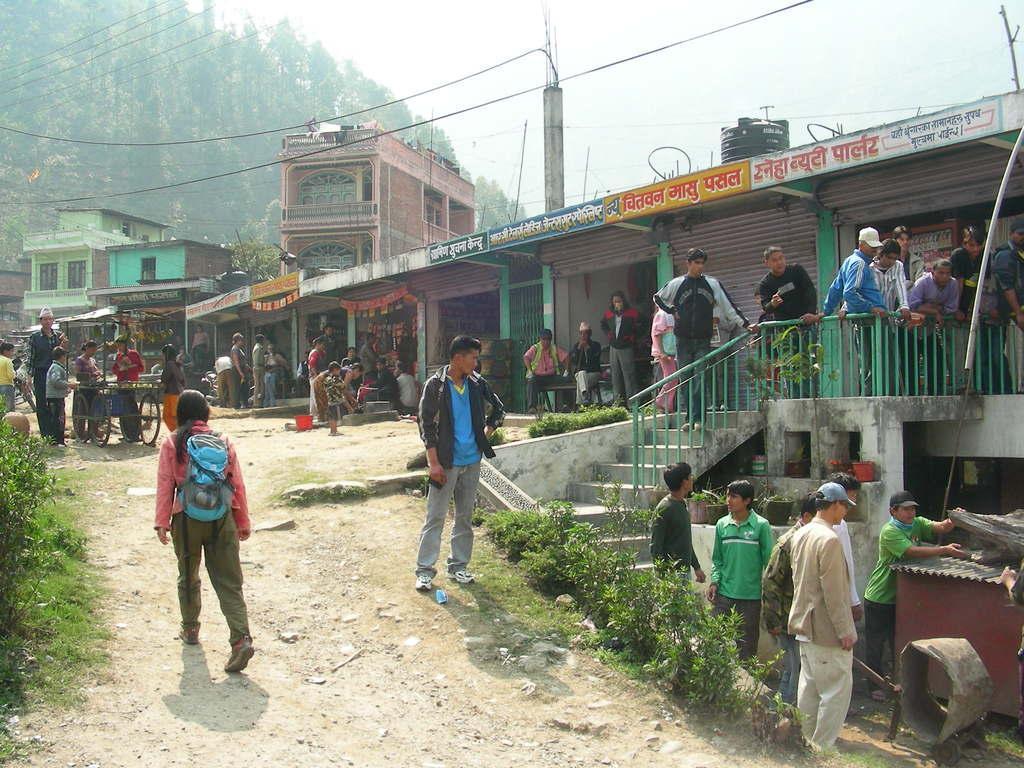Could you give a brief overview of what you see in this image? In this image, we can see buildings, trees, poles along with wires and we can see sheds, people, plants and there are people selling fruits on the bicycle and we can see a bucket, banners, boards, stairs, flower pots, logs and we can see a box which is in maroon color. At the bottom, there is ground and at the top, there is sky. 